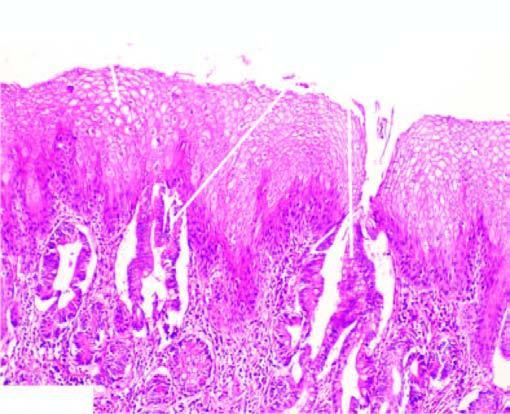does part of the endocervical mucosa undergo metaplastic change to columnar epithelium of intestinal type?
Answer the question using a single word or phrase. No 